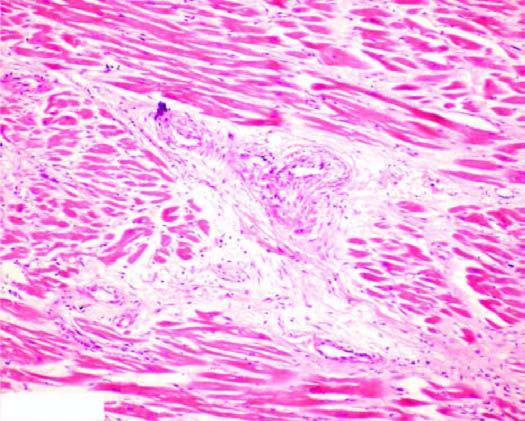s one marrow patchy myocardial fibrosis, especially around small blood vessels in the interstitium?
Answer the question using a single word or phrase. No 